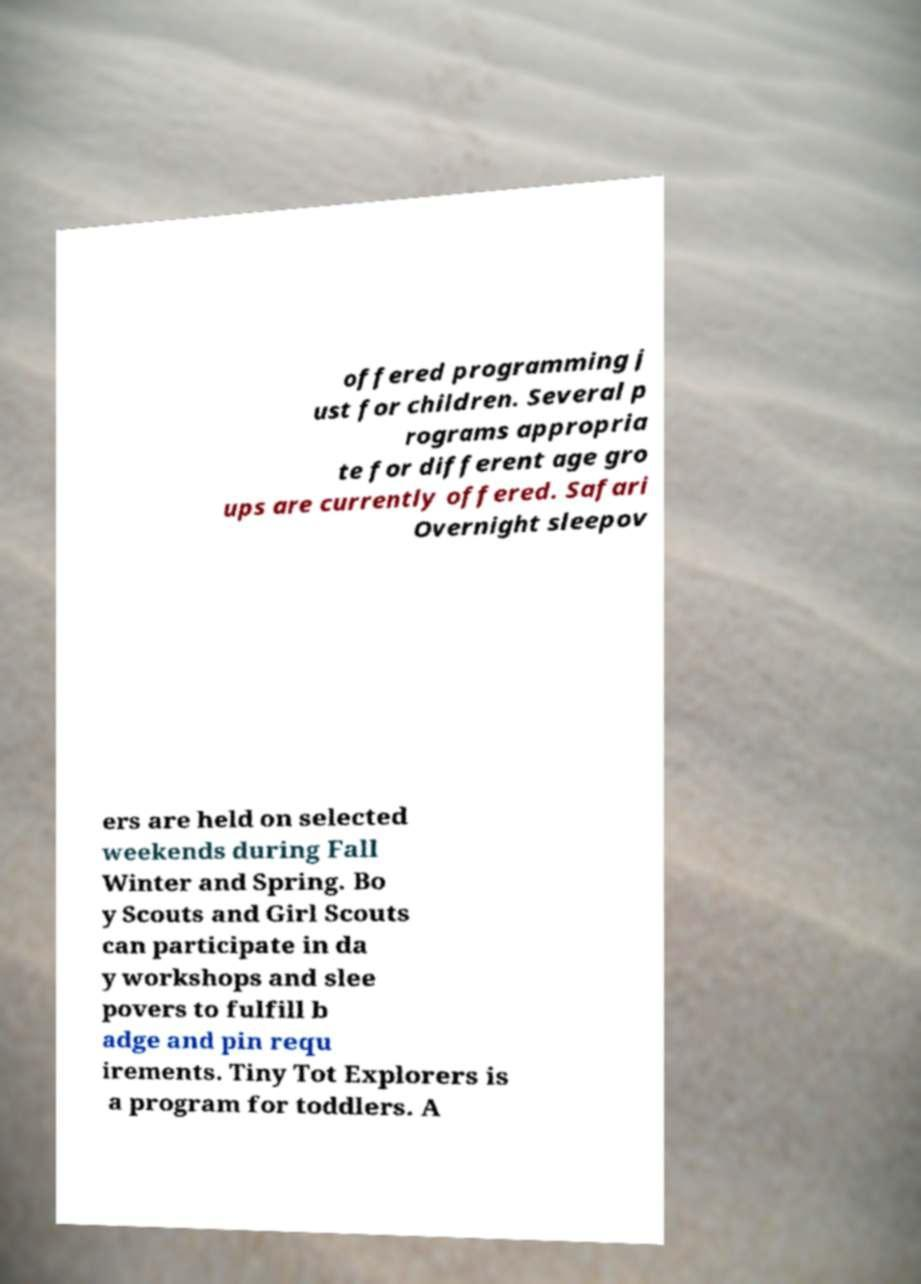Could you assist in decoding the text presented in this image and type it out clearly? offered programming j ust for children. Several p rograms appropria te for different age gro ups are currently offered. Safari Overnight sleepov ers are held on selected weekends during Fall Winter and Spring. Bo y Scouts and Girl Scouts can participate in da y workshops and slee povers to fulfill b adge and pin requ irements. Tiny Tot Explorers is a program for toddlers. A 